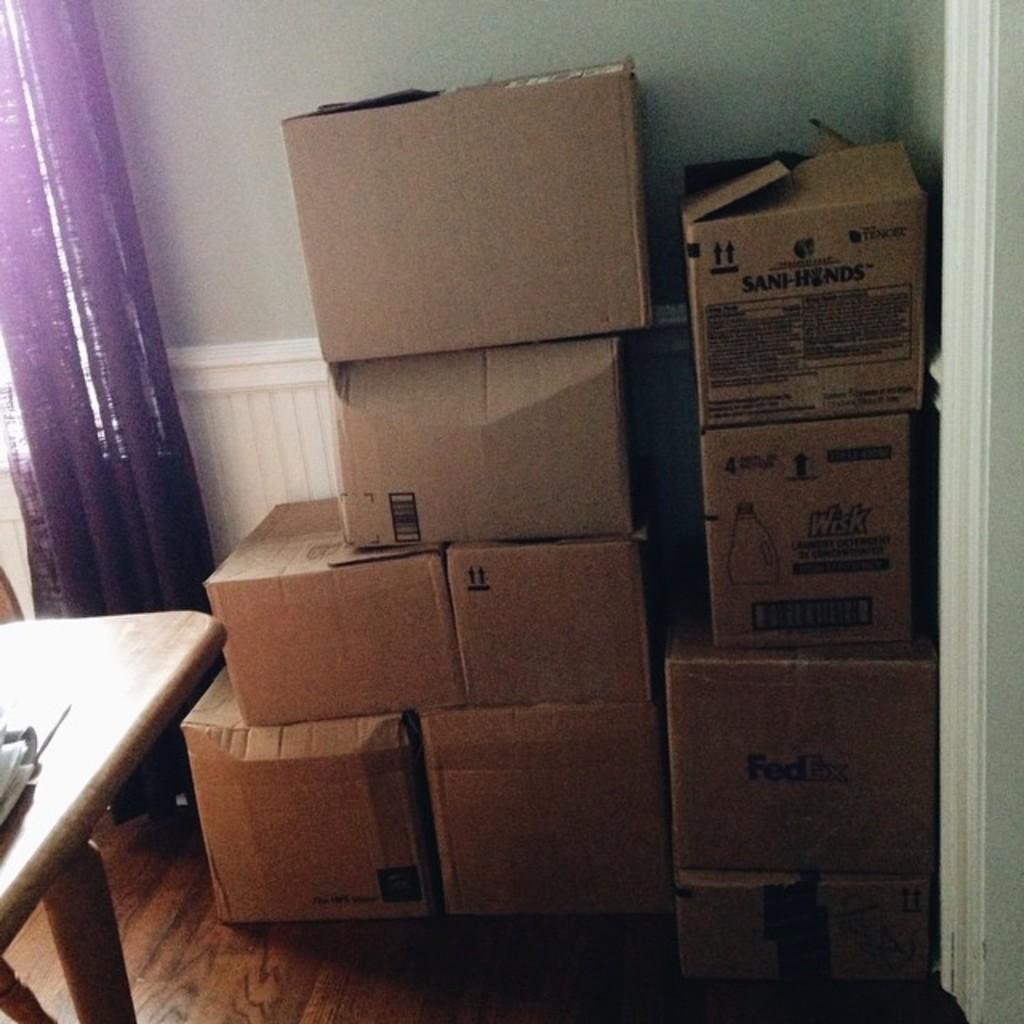How would you summarize this image in a sentence or two? This image is taken in the room. In the center of the image there are cardboard boxes. On the left there is a table. In the background there is a curtain and a wall. 